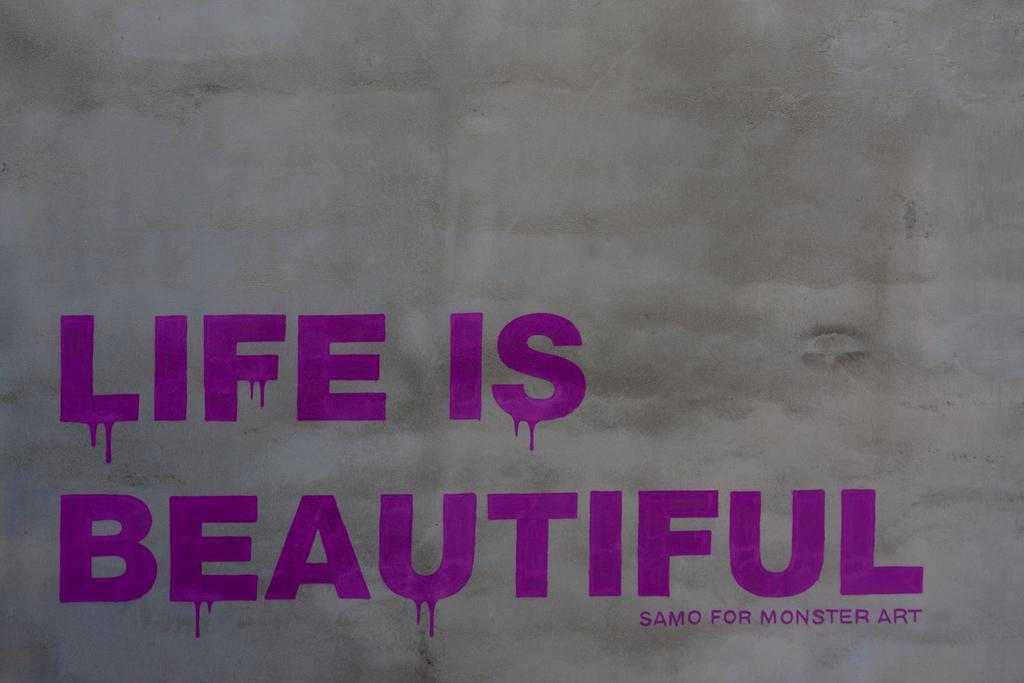<image>
Share a concise interpretation of the image provided. Purple letters spell Life is Beautiful and samo for monster art 